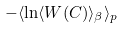<formula> <loc_0><loc_0><loc_500><loc_500>- \langle \ln \langle W ( C ) \rangle _ { \beta } \rangle _ { p }</formula> 